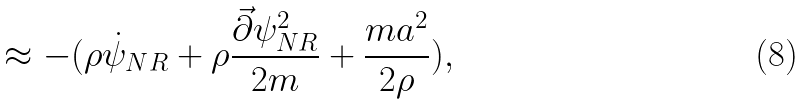Convert formula to latex. <formula><loc_0><loc_0><loc_500><loc_500>\approx - ( \rho \dot { \psi } _ { N R } + \rho \frac { \vec { \partial } \psi ^ { 2 } _ { N R } } { 2 m } + \frac { m a ^ { 2 } } { 2 \rho } ) ,</formula> 